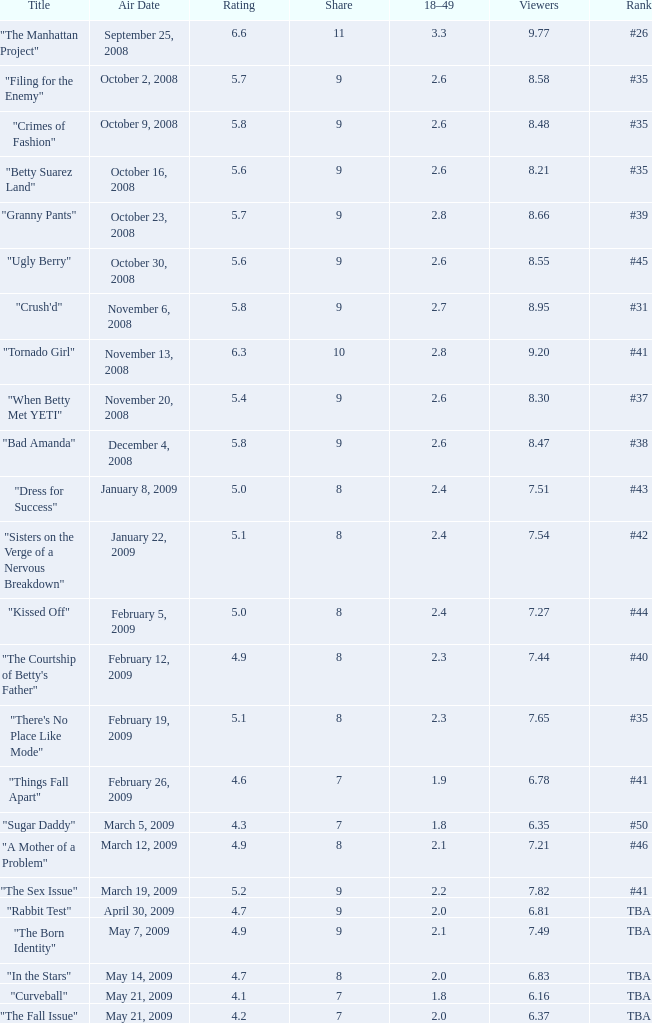What is the total number of Viewers when the rank is #40? 1.0. 